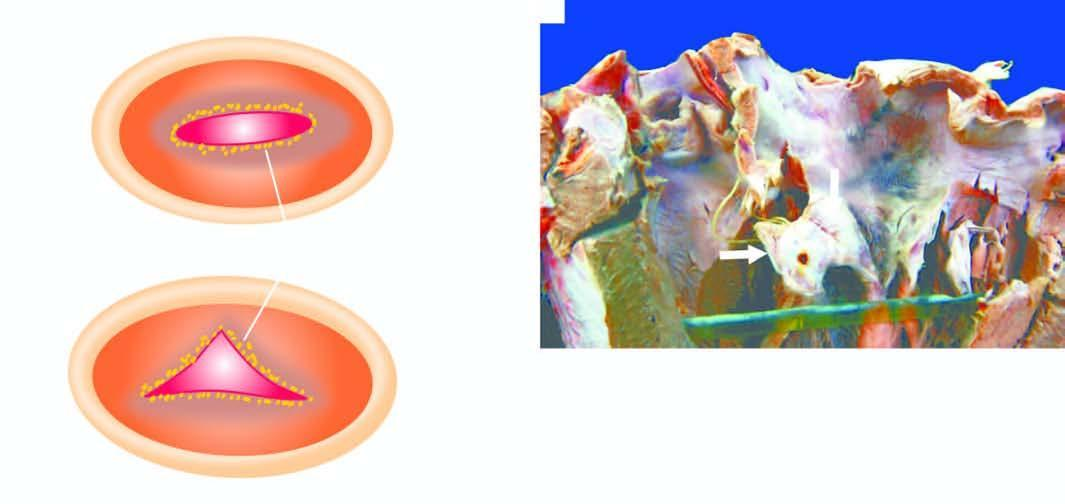does a, the pink acellular amyloid material show tiny firm granular vegetations?
Answer the question using a single word or phrase. No 